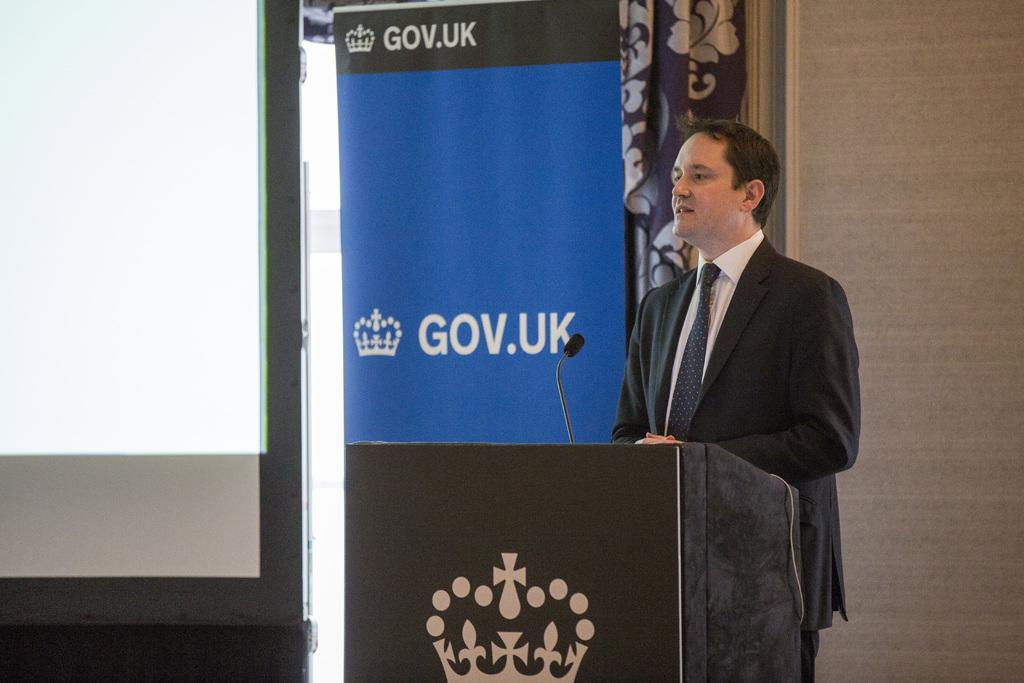What is the man in the image doing? The man is standing at the podium in the image. What is attached to the podium? A mic is attached to the podium. What can be seen in the background of the image? There are curtains and a display screen in the background. What type of music is being played by the tomatoes on the display screen? There are no tomatoes present in the image, and therefore no music can be attributed to them. 